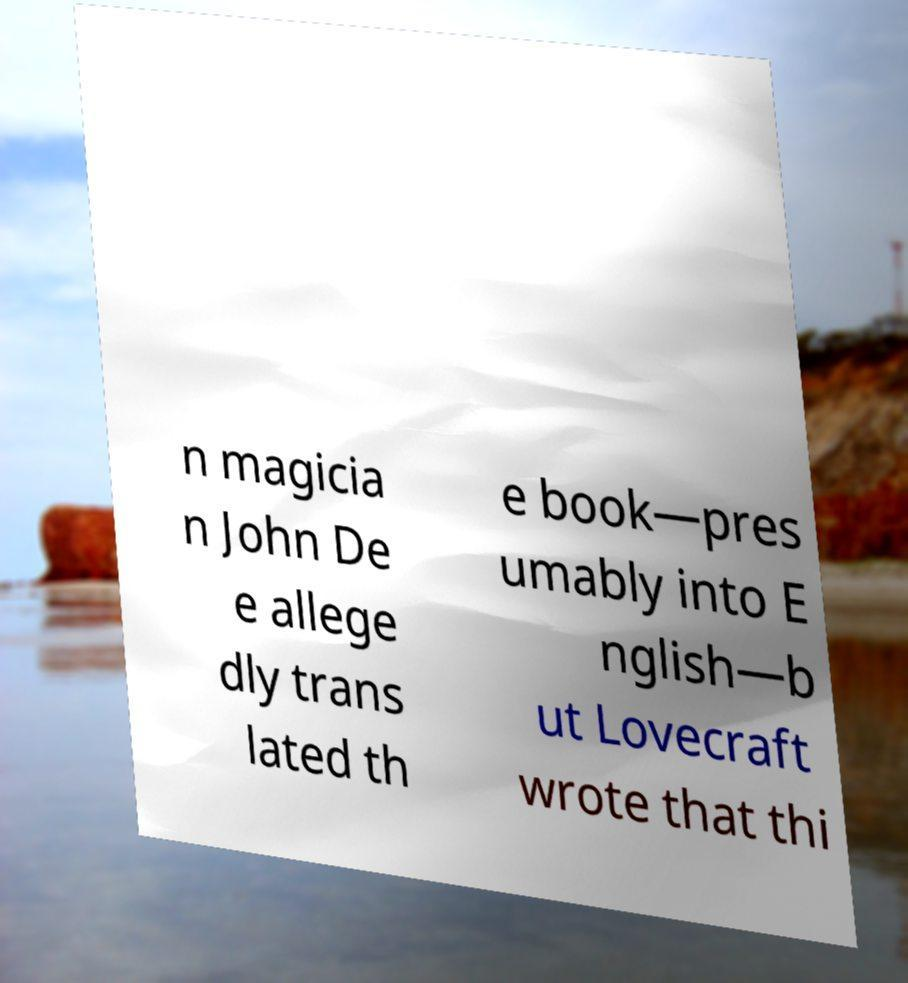Please identify and transcribe the text found in this image. n magicia n John De e allege dly trans lated th e book—pres umably into E nglish—b ut Lovecraft wrote that thi 